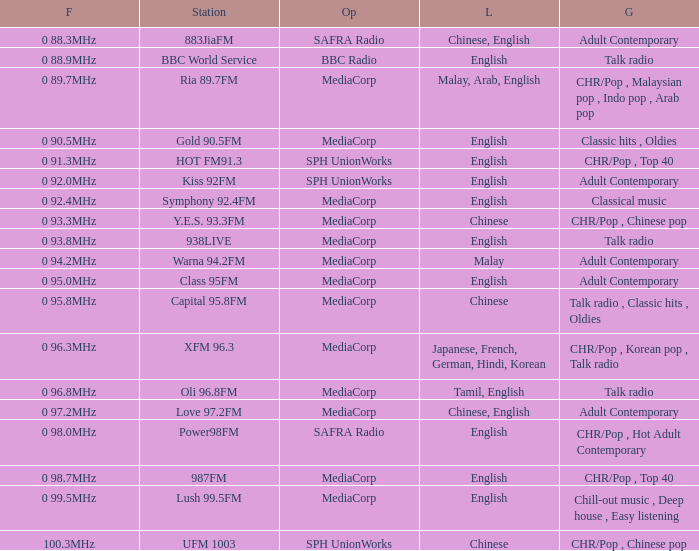What category does a station of class 95fm belong to? Adult Contemporary. 